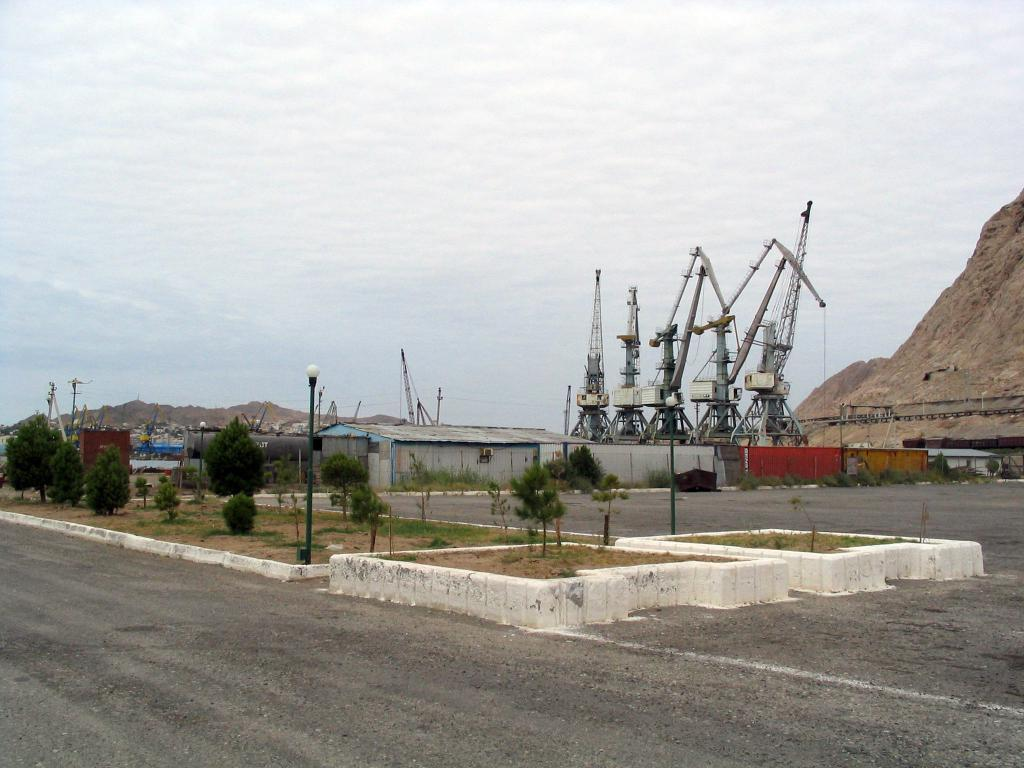What type of vegetation can be seen in the image? There are trees in the image. What type of artificial light sources are present in the image? There are street lamps in the image. What type of building is visible in the image? There is a house in the image. What type of infrastructure is present in the image? There are current poles in the image. What type of natural landform is visible in the image? There is a hill in the image. What part of the natural environment is visible in the image? The sky is visible in the image. Where is the seat located in the image? There is no seat present in the image. What type of leaf is visible on the trees in the image? There is no specific type of leaf mentioned in the image, only that there are trees present. 